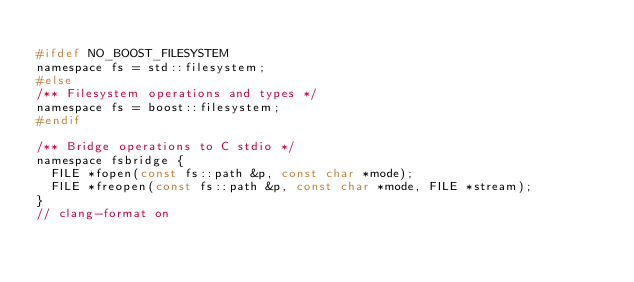<code> <loc_0><loc_0><loc_500><loc_500><_C_>
#ifdef NO_BOOST_FILESYSTEM
namespace fs = std::filesystem;
#else
/** Filesystem operations and types */
namespace fs = boost::filesystem;
#endif

/** Bridge operations to C stdio */
namespace fsbridge {
  FILE *fopen(const fs::path &p, const char *mode);
  FILE *freopen(const fs::path &p, const char *mode, FILE *stream);
}
// clang-format on
</code> 